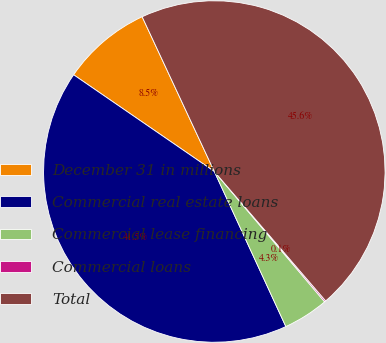Convert chart. <chart><loc_0><loc_0><loc_500><loc_500><pie_chart><fcel>December 31 in millions<fcel>Commercial real estate loans<fcel>Commercial lease financing<fcel>Commercial loans<fcel>Total<nl><fcel>8.47%<fcel>41.47%<fcel>4.3%<fcel>0.13%<fcel>45.64%<nl></chart> 